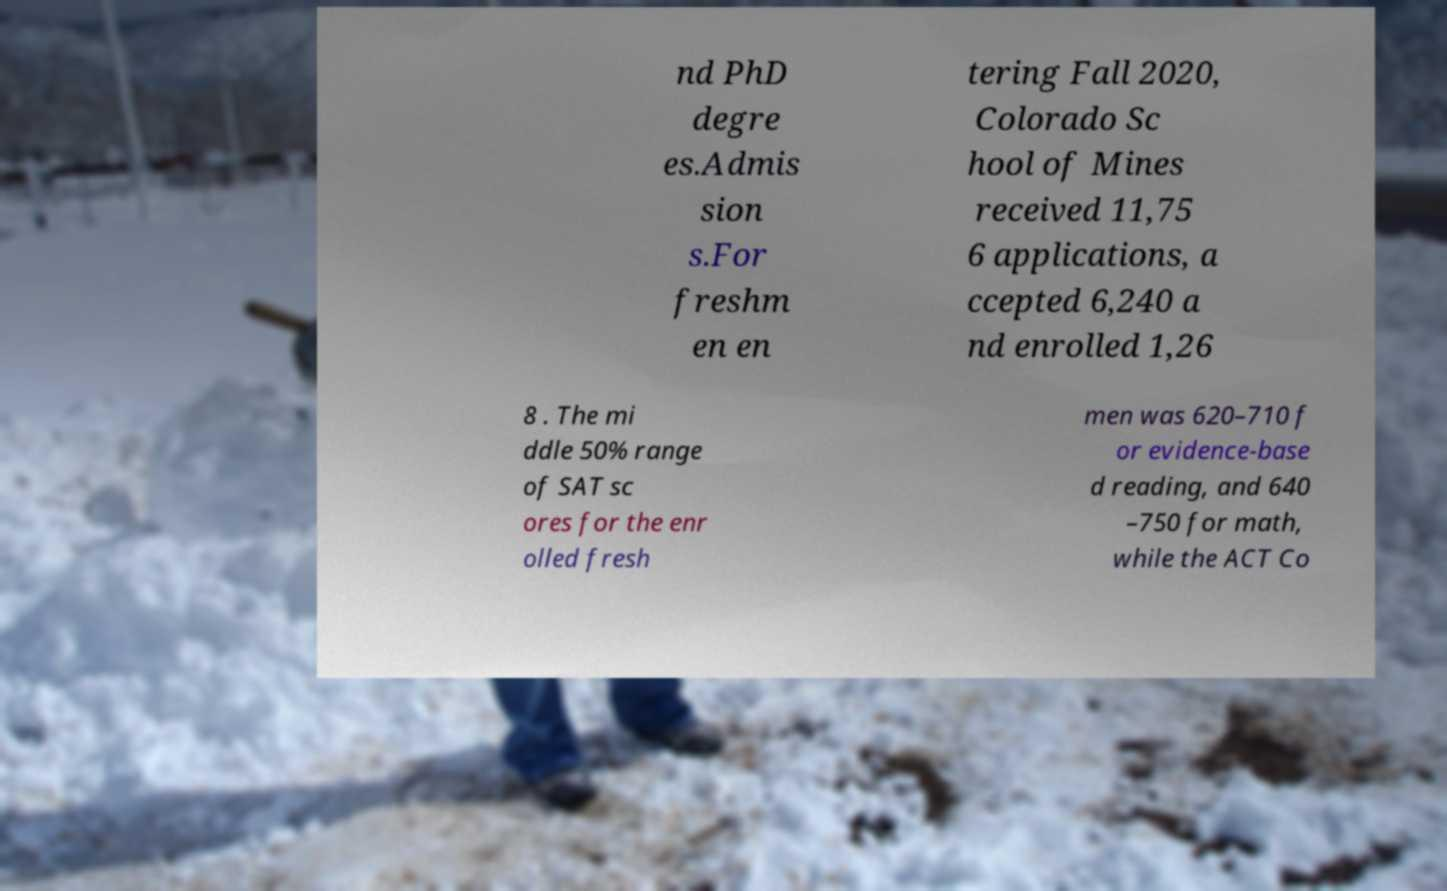Could you assist in decoding the text presented in this image and type it out clearly? nd PhD degre es.Admis sion s.For freshm en en tering Fall 2020, Colorado Sc hool of Mines received 11,75 6 applications, a ccepted 6,240 a nd enrolled 1,26 8 . The mi ddle 50% range of SAT sc ores for the enr olled fresh men was 620–710 f or evidence-base d reading, and 640 –750 for math, while the ACT Co 